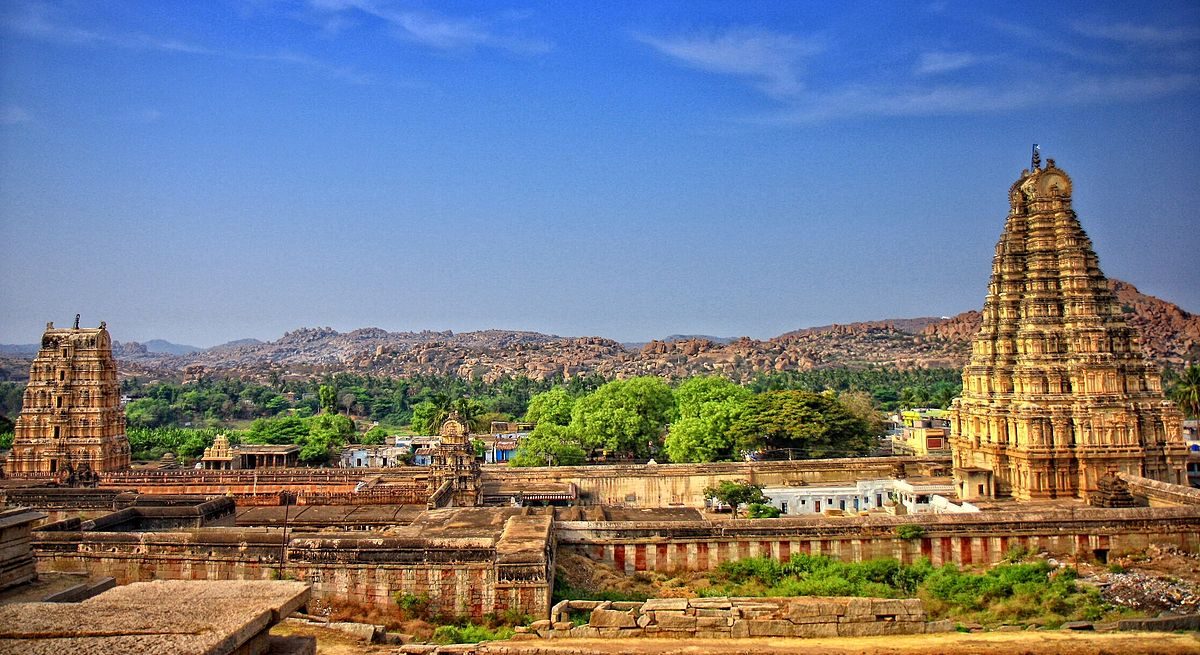Describe a typical day at Virupaksha Temple during a major festival. During a major festival, such as Maha Shivaratri, Virupaksha Temple transforms into a vibrant, bustling epicenter of devotion and celebration. Early in the morning, devotees start pouring into the temple complex, their voices blending in collective prayers and chants. The air is thick with the fragrance of incense, flowers, and temple offerings. Throughout the day, various rituals and ceremonies take place, including abhishekam (sacred bath), alankaram (decoration), and aarti (ritual of light).

The temple is adorned with intricate rangoli (decorative motifs made with colored powders) at its entrance, and its gopurams are draped in colorful fabrics and lit up beautifully as evening approaches. Cultural performances such as classical dance and devotional music fill the air with spiritual ambiance. Vendors set up stalls selling sweets, snacks, and souvenirs, adding to the festive atmosphere.

As night falls, the temple grounds are bathed in the glow of countless oil lamps, creating a mesmerizing view. The grand procession of the deity in a chariot, accompanied by a sea of devotees, marks the climax of the celebration. The entire area reverberates with the sound of drums, bells, and chanting, drawing an emotional and spiritual connection among all present. 